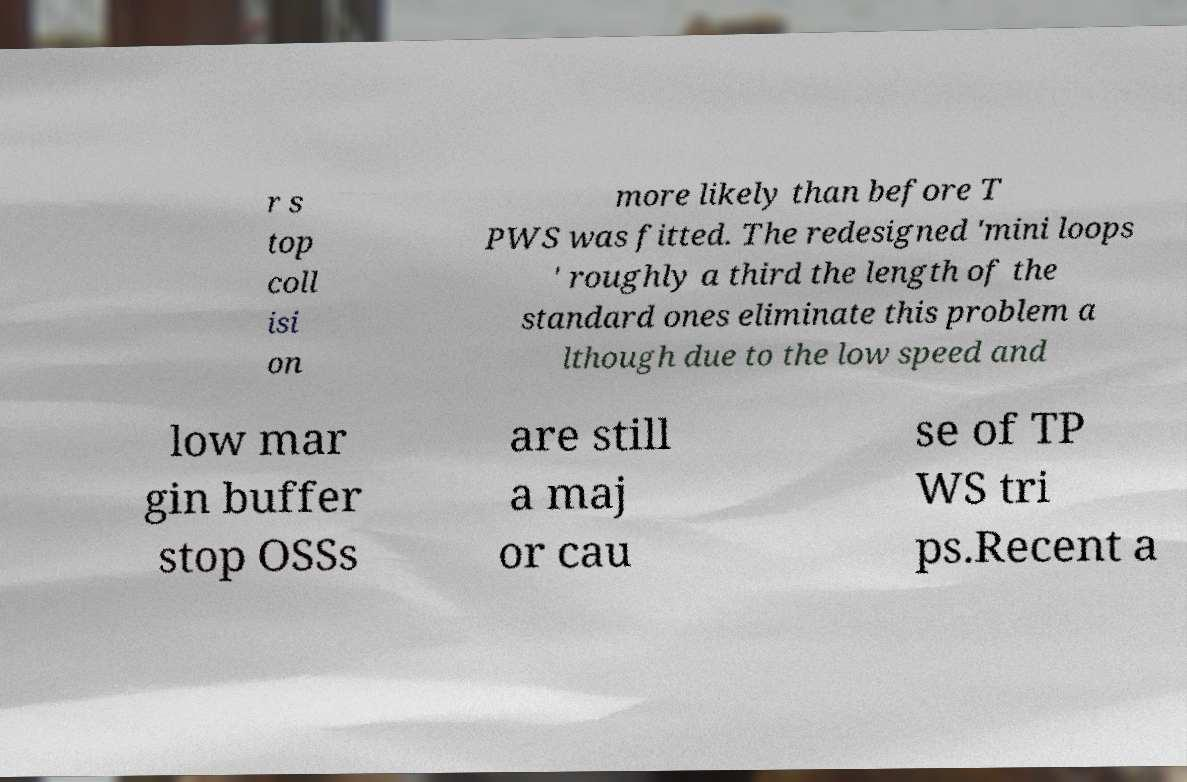What messages or text are displayed in this image? I need them in a readable, typed format. r s top coll isi on more likely than before T PWS was fitted. The redesigned 'mini loops ' roughly a third the length of the standard ones eliminate this problem a lthough due to the low speed and low mar gin buffer stop OSSs are still a maj or cau se of TP WS tri ps.Recent a 